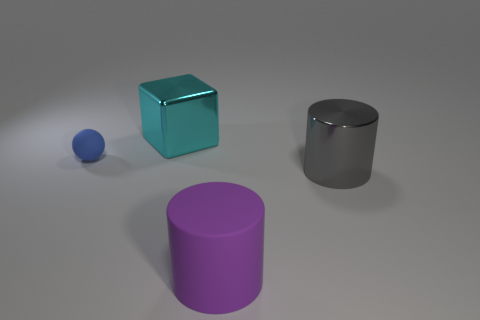Add 1 cyan things. How many objects exist? 5 Subtract all cubes. How many objects are left? 3 Subtract all purple matte cylinders. Subtract all large rubber cylinders. How many objects are left? 2 Add 3 big shiny cylinders. How many big shiny cylinders are left? 4 Add 4 big brown matte things. How many big brown matte things exist? 4 Subtract 0 yellow blocks. How many objects are left? 4 